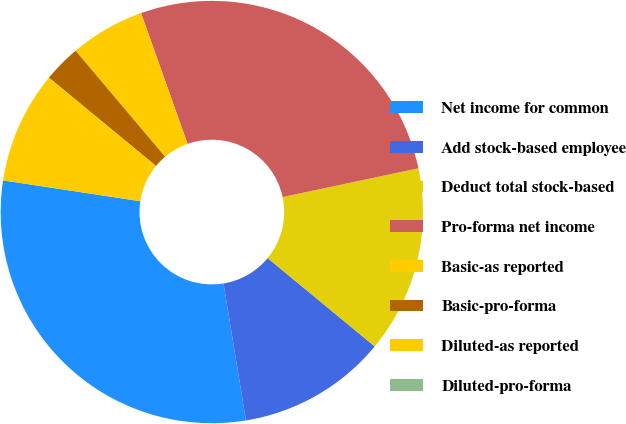<chart> <loc_0><loc_0><loc_500><loc_500><pie_chart><fcel>Net income for common<fcel>Add stock-based employee<fcel>Deduct total stock-based<fcel>Pro-forma net income<fcel>Basic-as reported<fcel>Basic-pro-forma<fcel>Diluted-as reported<fcel>Diluted-pro-forma<nl><fcel>29.98%<fcel>11.44%<fcel>14.3%<fcel>27.12%<fcel>5.72%<fcel>2.86%<fcel>8.58%<fcel>0.0%<nl></chart> 